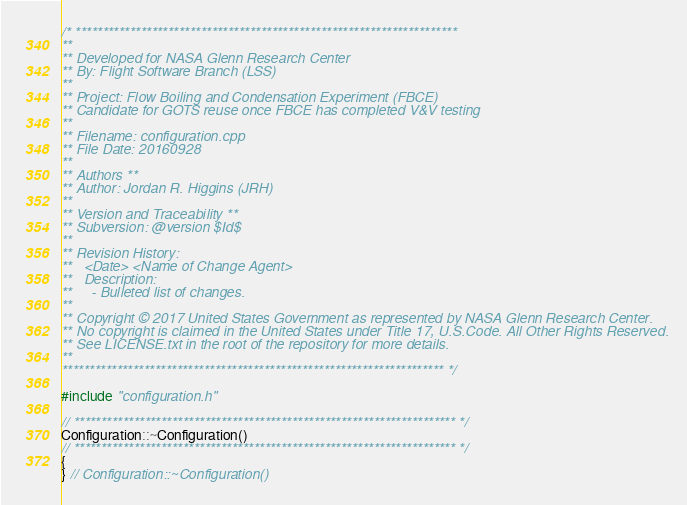<code> <loc_0><loc_0><loc_500><loc_500><_C++_>/* **********************************************************************
**
** Developed for NASA Glenn Research Center
** By: Flight Software Branch (LSS)
**
** Project: Flow Boiling and Condensation Experiment (FBCE)
** Candidate for GOTS reuse once FBCE has completed V&V testing
**
** Filename: configuration.cpp
** File Date: 20160928
**
** Authors **
** Author: Jordan R. Higgins (JRH)
**
** Version and Traceability **
** Subversion: @version $Id$
**
** Revision History:
**   <Date> <Name of Change Agent>
**   Description:
**     - Bulleted list of changes.
**
** Copyright © 2017 United States Government as represented by NASA Glenn Research Center.
** No copyright is claimed in the United States under Title 17, U.S.Code. All Other Rights Reserved.
** See LICENSE.txt in the root of the repository for more details.
**
********************************************************************** */

#include "configuration.h"

// ********************************************************************** */
Configuration::~Configuration()
// ********************************************************************** */
{
} // Configuration::~Configuration()
</code> 